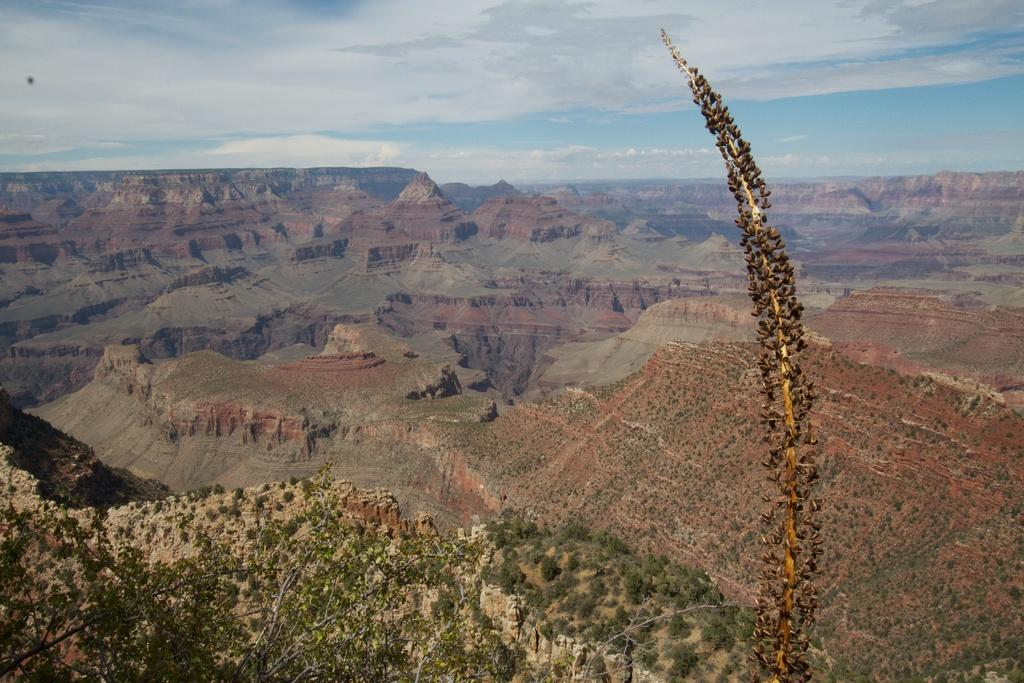What type of landscape is visible in the image? There are hills with grass and plants in the image. From what perspective is the image taken? The image is taken from an aerial view. What can be seen in the background of the image? In the background, there is a sky visible. What is the condition of the sky in the image? Clouds are present in the sky. How many jellyfish can be seen swimming in the hills in the image? There are no jellyfish present in the image; it features hills with grass and plants. What type of headwear is worn by the hills in the image? The hills in the image do not wear any headwear, as they are natural landforms. 